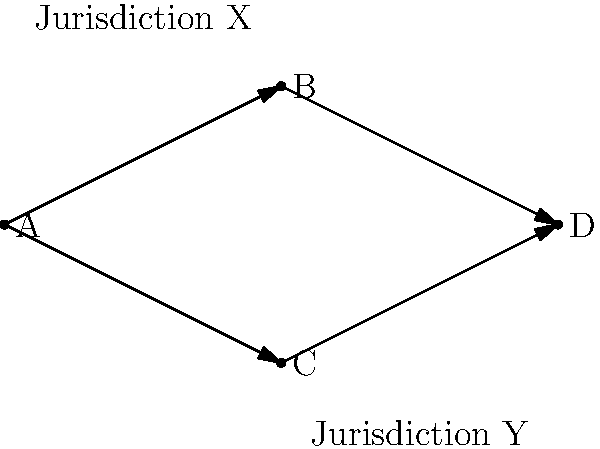In the topological structure of an NFT marketplace shown above, nodes represent different components of the system (A: Seller, B: Smart Contract, C: Buyer, D: NFT Storage). The marketplace operates across two jurisdictions (X and Y). If a legal dispute arises between the seller in Jurisdiction X and the buyer in Jurisdiction Y, which component of the system would likely be the focal point for determining legal jurisdiction, and why? To determine the focal point for legal jurisdiction in this NFT marketplace structure, we need to consider the following steps:

1. Identify the key components:
   A: Seller (Jurisdiction X)
   B: Smart Contract
   C: Buyer (Jurisdiction Y)
   D: NFT Storage

2. Analyze the connections:
   - The seller (A) and buyer (C) are in different jurisdictions.
   - Both connect to the smart contract (B).
   - The smart contract (B) connects to the NFT storage (D).

3. Consider the role of each component:
   - The seller and buyer are end-users and typically subject to their local jurisdictions.
   - The NFT storage (D) is a passive component that holds the digital asset.
   - The smart contract (B) is the central component that facilitates the transaction and enforces the terms.

4. Evaluate the smart contract's significance:
   - It acts as an intermediary between jurisdictions.
   - It contains the terms of the agreement between parties.
   - It executes the transfer of ownership and manages the transaction.

5. Assess the legal implications:
   - Smart contracts are often considered self-executing and autonomous.
   - The jurisdiction of the smart contract can be critical in determining which laws apply.
   - The location or governing law of the smart contract may be specified in the marketplace's terms of service.

6. Conclusion:
   The smart contract (B) would likely be the focal point for determining legal jurisdiction because:
   - It bridges the two jurisdictions involved.
   - It contains the core logic and terms of the transaction.
   - Its governing law or place of execution could be used to establish jurisdiction in cross-border disputes.
Answer: Smart Contract (Node B) 